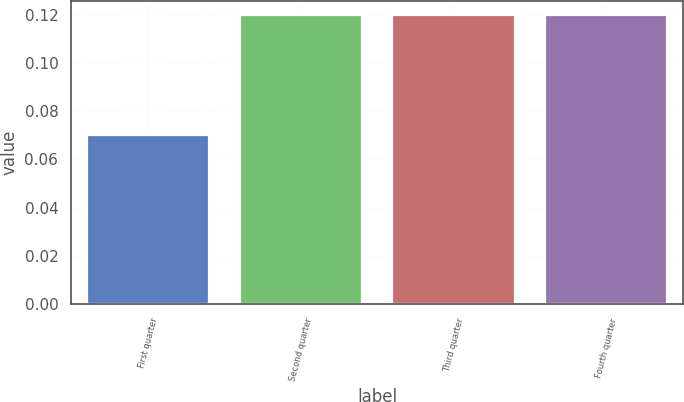<chart> <loc_0><loc_0><loc_500><loc_500><bar_chart><fcel>First quarter<fcel>Second quarter<fcel>Third quarter<fcel>Fourth quarter<nl><fcel>0.07<fcel>0.12<fcel>0.12<fcel>0.12<nl></chart> 